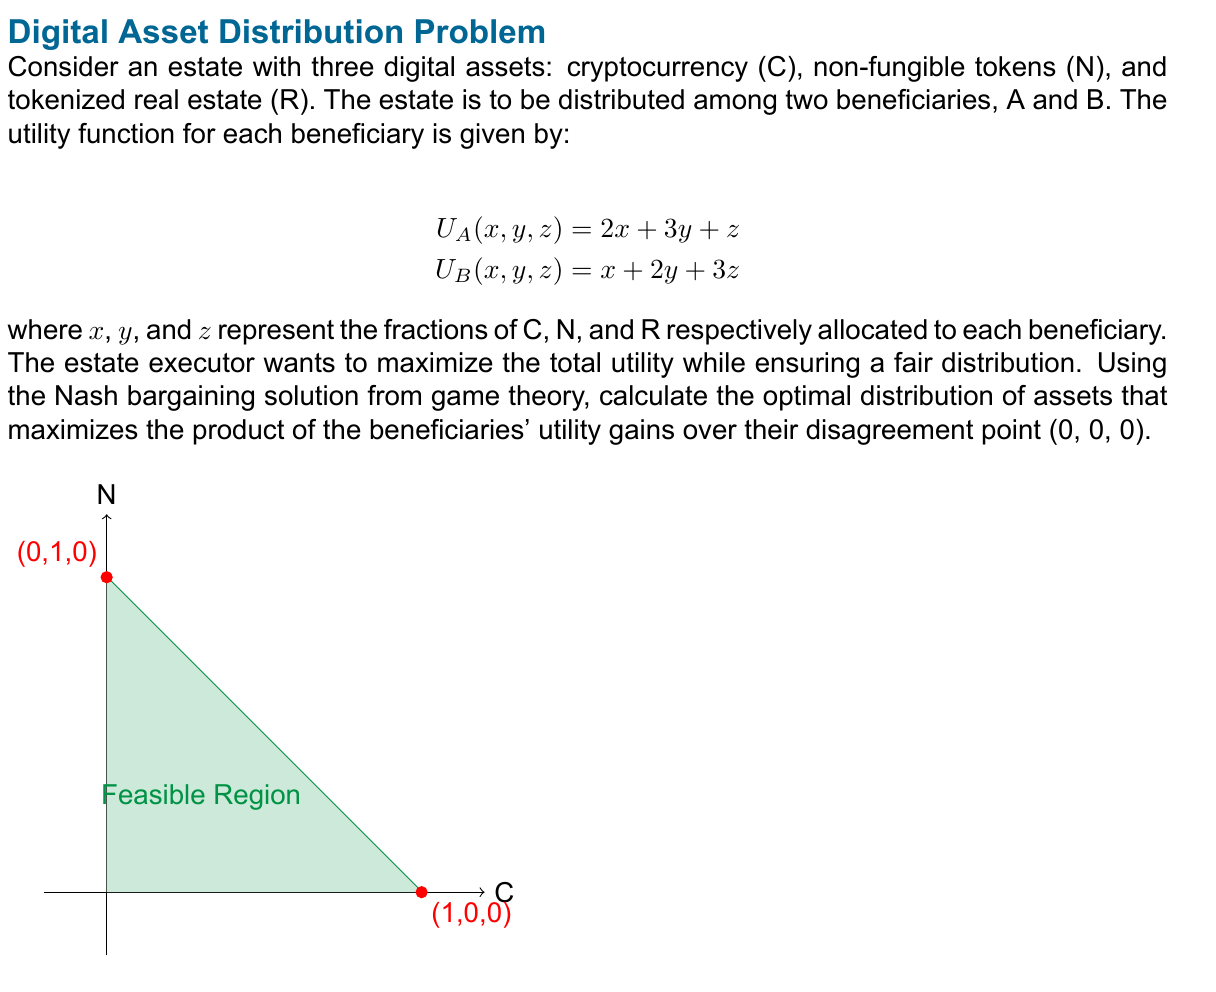Provide a solution to this math problem. To solve this problem, we'll follow these steps:

1) First, we need to set up the Nash bargaining problem. The Nash bargaining solution maximizes the product of utility gains:

   $$\max (U_A - U_A^d)(U_B - U_B^d)$$

   where $U_A^d$ and $U_B^d$ are the disagreement utilities, both 0 in this case.

2) Given the constraints that the fractions must sum to 1:

   $$x + y + z = 1$$

3) We can substitute $z = 1 - x - y$ into our utility functions:

   $$U_A(x, y) = 2x + 3y + (1-x-y) = x + 2y + 1$$
   $$U_B(x, y) = x + 2y + 3(1-x-y) = -2x - y + 3$$

4) Now our optimization problem becomes:

   $$\max (x + 2y + 1)(-2x - y + 3)$$

5) Expanding this:

   $$\max -2x^2 - xy - 5x - 2y^2 + 5y + 3$$

6) To find the maximum, we take partial derivatives and set them to zero:

   $$\frac{\partial}{\partial x} = -4x - y - 5 = 0$$
   $$\frac{\partial}{\partial y} = -x - 4y + 5 = 0$$

7) Solving this system of equations:

   From the second equation: $x = 5 - 4y$
   Substituting into the first: $-4(5-4y) - y - 5 = 0$
   $-20 + 16y - y - 5 = 0$
   $15y = 25$
   $y = \frac{5}{3}$

   Substituting back: $x = 5 - 4(\frac{5}{3}) = \frac{5}{3}$

8) Since $x + y + z = 1$, we can find $z$:

   $z = 1 - \frac{5}{3} - \frac{5}{3} = -\frac{7}{3}$

9) However, this solution is outside our feasible region (z cannot be negative). This means our solution lies on the boundary where $z = 0$.

10) With $z = 0$, our problem reduces to maximizing:

    $$\max (2x + 3y)(x + 2y)$$ subject to $x + y = 1$

11) We can substitute $y = 1 - x$ to get:

    $$\max (2x + 3(1-x))(x + 2(1-x)) = (3-x)(2-x)$$

12) Expanding:

    $$\max 6 - 5x + x^2$$

13) Taking the derivative and setting to zero:

    $$-5 + 2x = 0$$
    $$x = \frac{5}{2}$$

14) Again, this is outside our feasible region. The maximum must therefore be at one of the endpoints: (1,0) or (0,1).

15) Evaluating:
    At (1,0): $(2)(1) = 2$
    At (0,1): $(3)(2) = 6$

Therefore, the optimal distribution is (0,1,0), meaning all NFTs should be allocated to one beneficiary.
Answer: (0,1,0) 